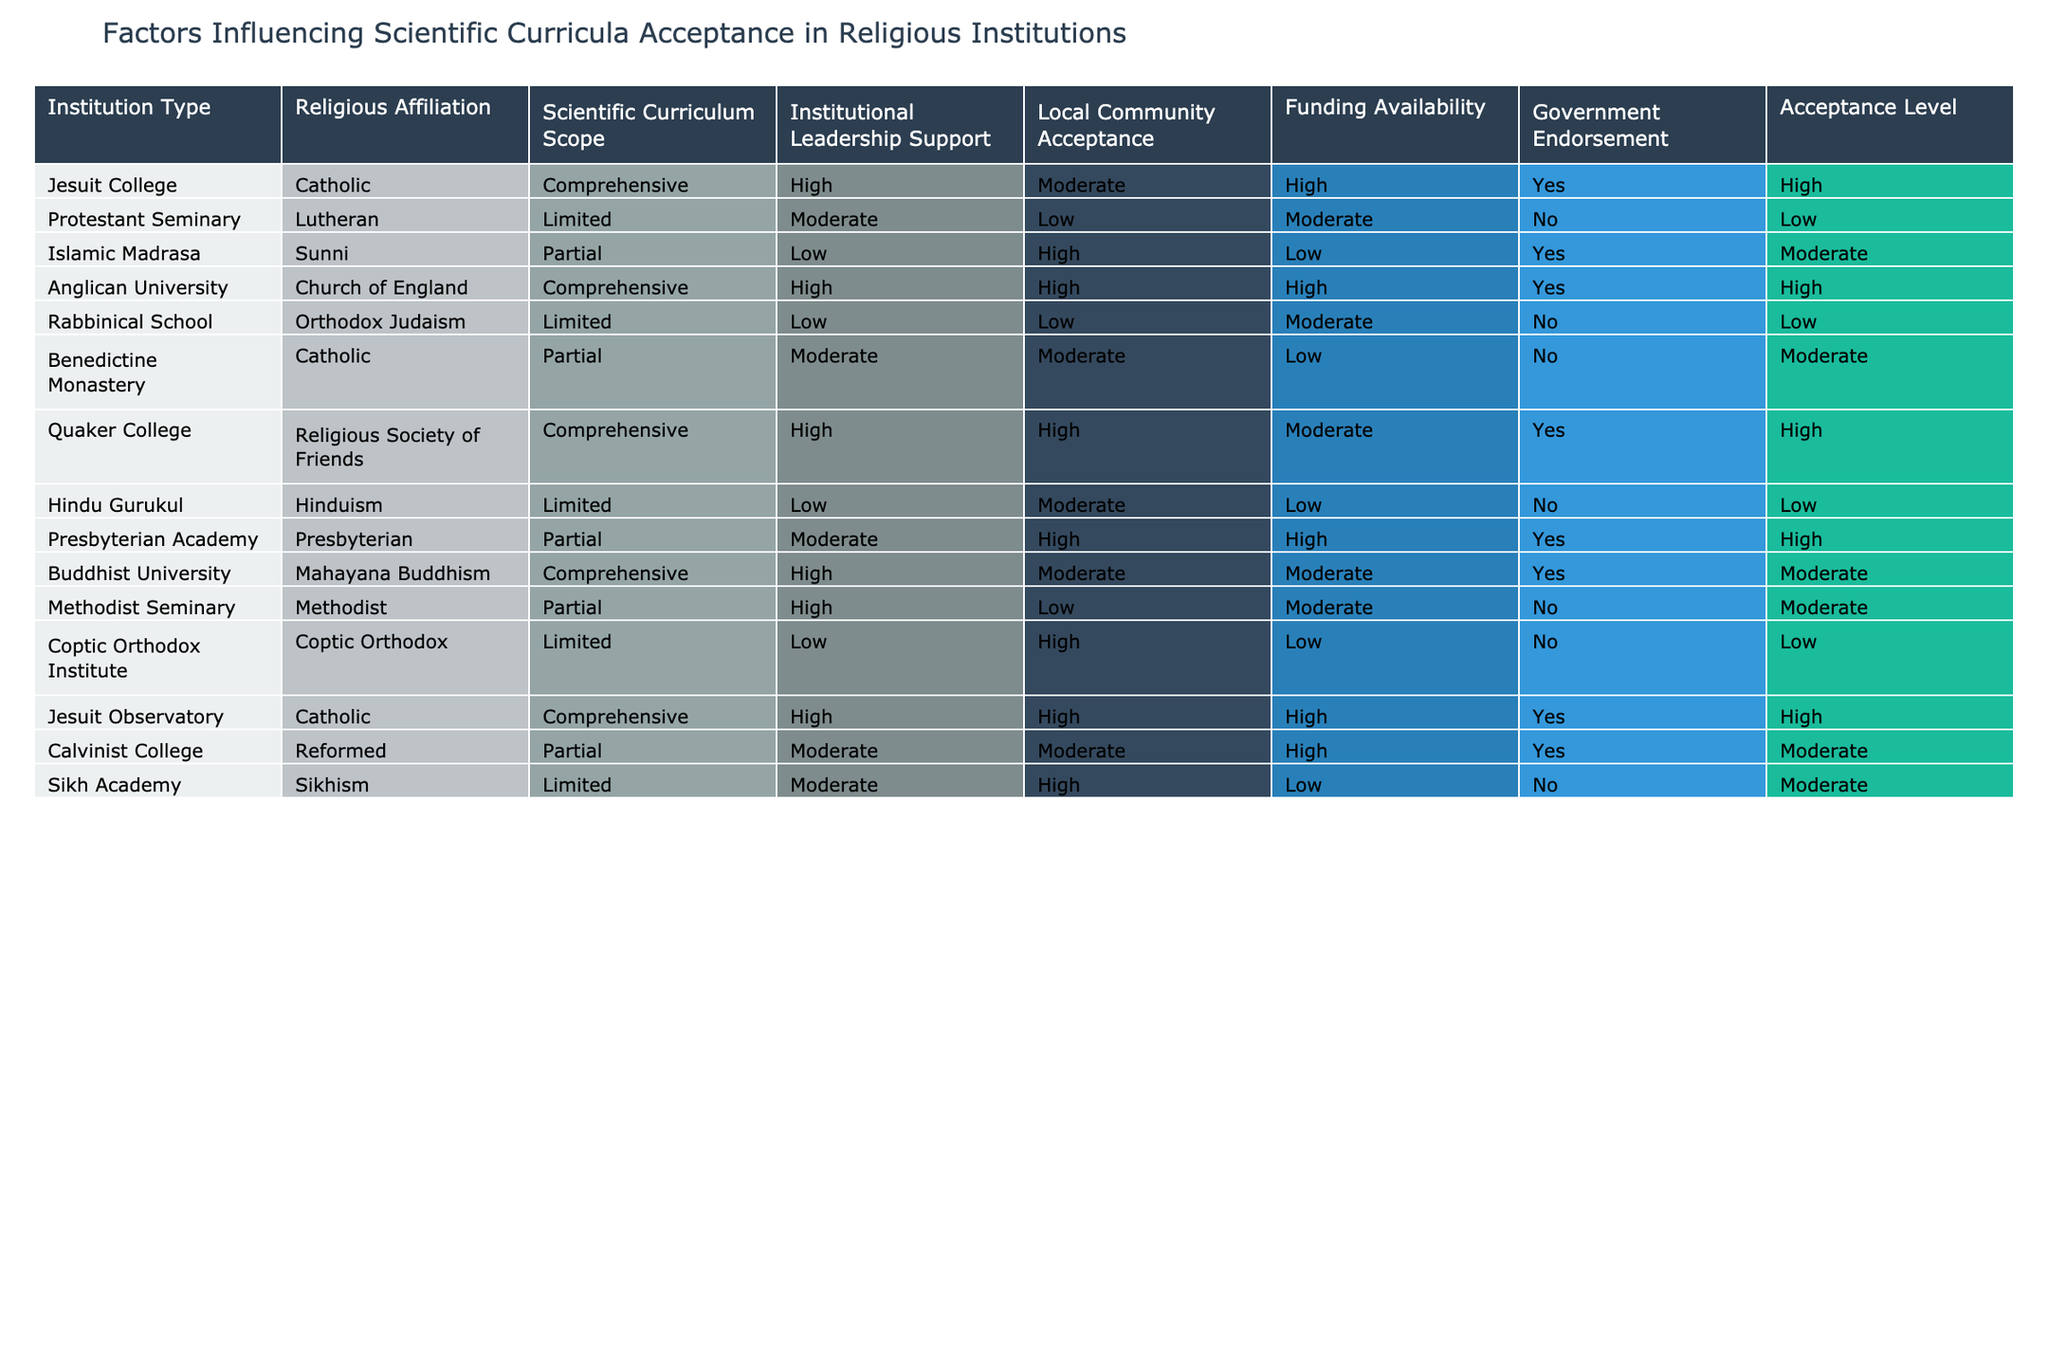What is the acceptance level of the Anglican University? The acceptance level of the Anglican University is listed directly in the table under Acceptance Level, which shows 'High'.
Answer: High How many institutions have government endorsement? To find the number of institutions with government endorsement, check the column 'Government Endorsement' for instances of 'Yes'. There are 6 institutions listed with 'Yes' in that column.
Answer: 6 Which religious affiliation has the highest percentage of high acceptance levels? By examining the 'Acceptance Level' column, the only affiliations that indicate 'High' acceptance are Catholic, Church of England, and Religious Society of Friends. Each has multiple institutions listed (3 in total). Calculating the percentage, we have 3 'High' acceptance levels out of a total of 16 institutions, which results in approximately 18.75%. This is the highest observed among those listed.
Answer: 18.75% Is there any institution type that has both high funding availability and high acceptance level? The institutions to look for are those with 'High' listed in both the 'Funding Availability' and 'Acceptance Level' columns. By checking through the table, both the Anglican University and the Jesuit Observatory meet these criteria.
Answer: Yes What is the average institutional leadership support level among Islamic and Protestant institutions? To determine the average, we first identify the values listed for leadership support for the Islamic Madrasa (Low) and Protestant Seminary (Moderate). Assigning numerical values (Low=1, Moderate=2, High=3), we translate: Islamic Madrasa = 1, Protestant Seminary = 2. The average becomes (1 + 2) / 2 = 1.5, which translates back to a 'Low-Moderate' level.
Answer: Low-Moderate Which institution has the lowest acceptance level, and what is its religious affiliation? Upon inspecting the 'Acceptance Level' column, we see that both the Protestant Seminary and the Rabbinical School have a low acceptance level. However, the Rabbinical School has a religious affiliation of Orthodox Judaism, which is confirmed by the respective columns for that institution.
Answer: Rabbinical School, Orthodox Judaism How many institutions with comprehensive curricula show high acceptance levels? By scanning for 'Comprehensive' under 'Scientific Curriculum Scope', we note Jesuit College, Anglican University, Quaker College, and Jesuit Observatory. Among these, Jesuit College, Anglican University, and Quaker College have high acceptance levels. Therefore, 3 institutions meet these criteria.
Answer: 3 Which institution has partial scientific curriculum and high funding availability? Looking through the table, we can match institutions with 'Partial' under 'Scientific Curriculum Scope' and 'High' under 'Funding Availability'. That is only the Calvinist College when checked against the corresponding columns.
Answer: Calvinist College 